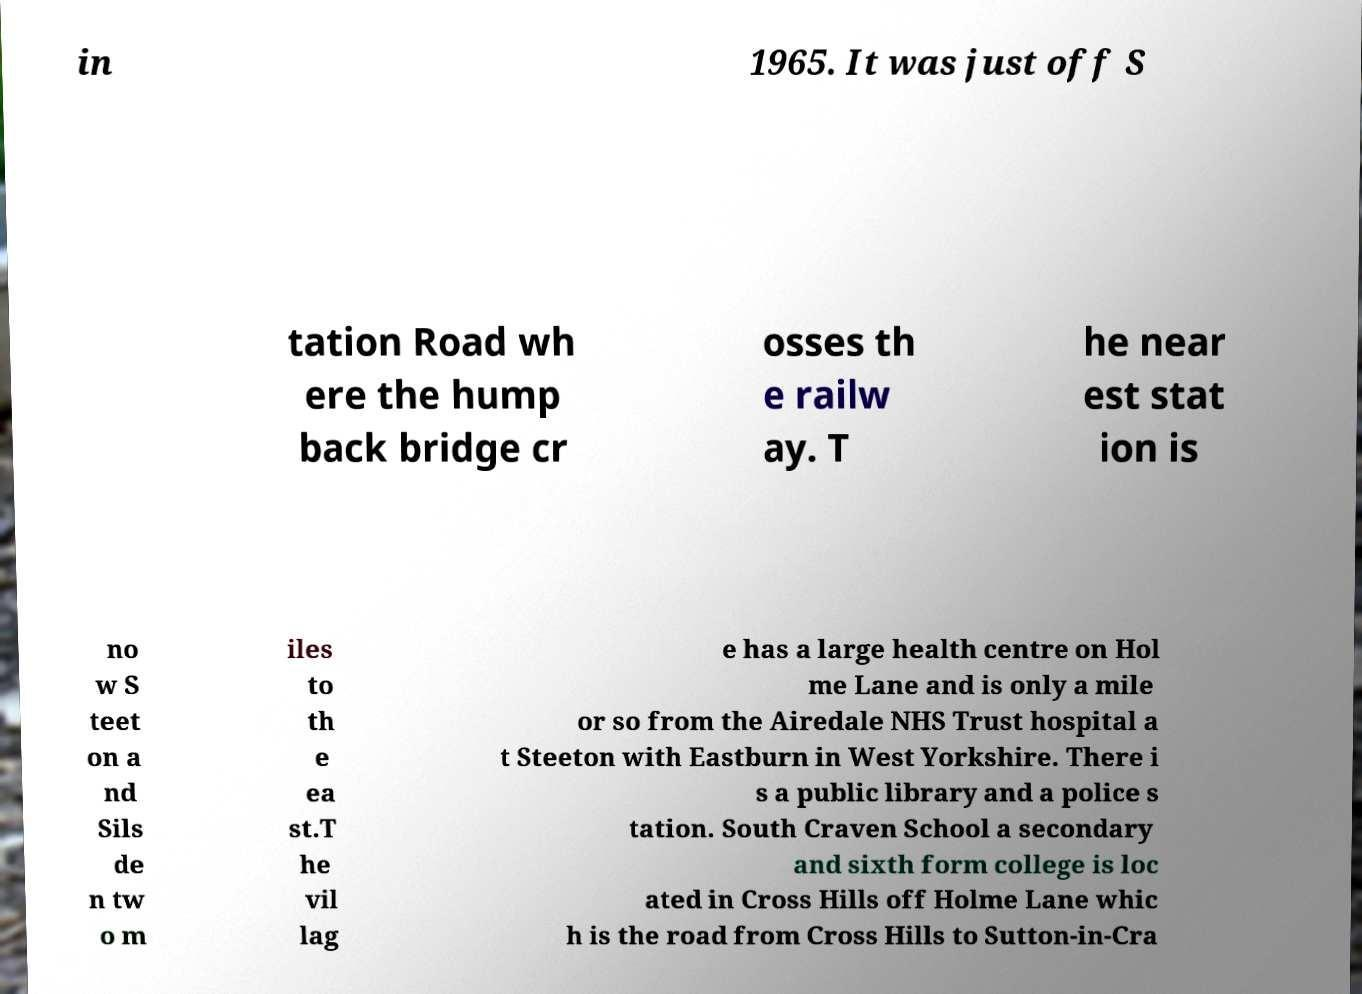What messages or text are displayed in this image? I need them in a readable, typed format. in 1965. It was just off S tation Road wh ere the hump back bridge cr osses th e railw ay. T he near est stat ion is no w S teet on a nd Sils de n tw o m iles to th e ea st.T he vil lag e has a large health centre on Hol me Lane and is only a mile or so from the Airedale NHS Trust hospital a t Steeton with Eastburn in West Yorkshire. There i s a public library and a police s tation. South Craven School a secondary and sixth form college is loc ated in Cross Hills off Holme Lane whic h is the road from Cross Hills to Sutton-in-Cra 